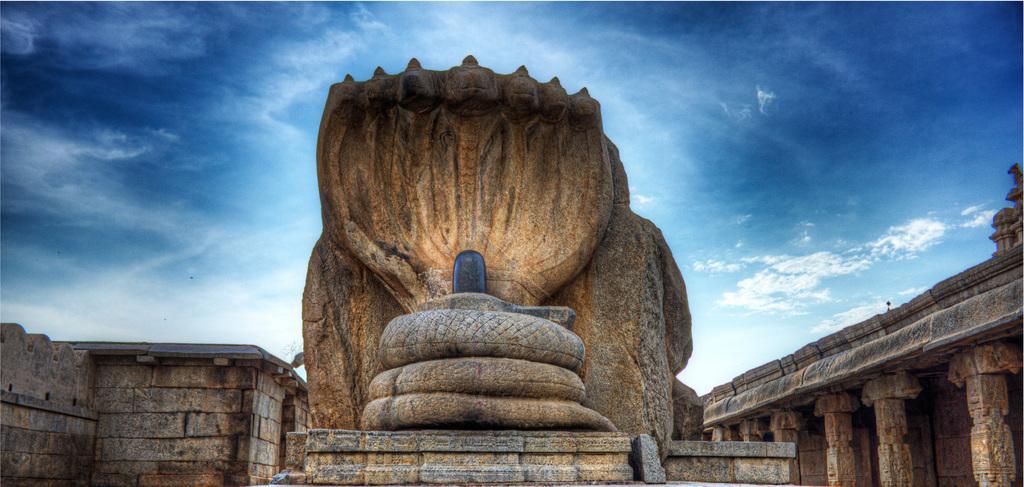How would you summarize this image in a sentence or two? In this image, in the middle, we can see a sculpture. On the right side, we can see some pillars. On the left side, we can see a wall. At the top, we can see a sky which is in blue color. 